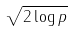<formula> <loc_0><loc_0><loc_500><loc_500>\sqrt { 2 \log p }</formula> 